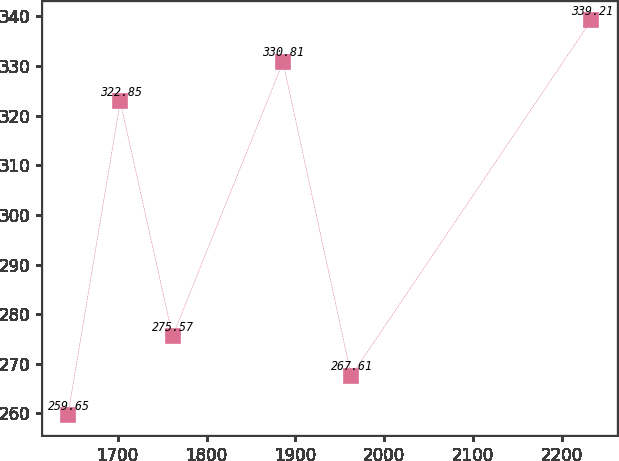Convert chart to OTSL. <chart><loc_0><loc_0><loc_500><loc_500><line_chart><ecel><fcel>Unnamed: 1<nl><fcel>1644.02<fcel>259.65<nl><fcel>1702.93<fcel>322.85<nl><fcel>1761.84<fcel>275.57<nl><fcel>1886.08<fcel>330.81<nl><fcel>1962.96<fcel>267.61<nl><fcel>2233.11<fcel>339.21<nl></chart> 